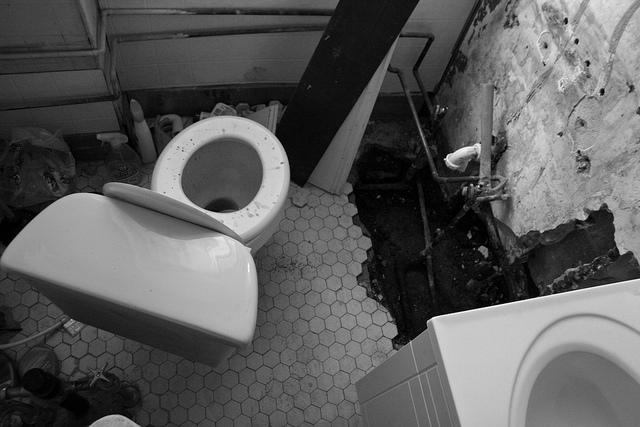What usually goes inside of the item with the lid? Please explain your reasoning. human waste. This is a toilet that people use to go to the bathroom in. 